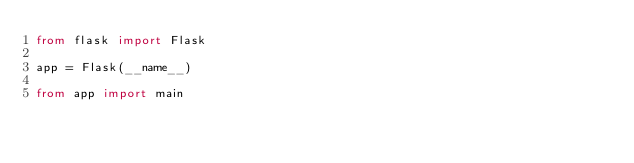Convert code to text. <code><loc_0><loc_0><loc_500><loc_500><_Python_>from flask import Flask

app = Flask(__name__)

from app import main
</code> 